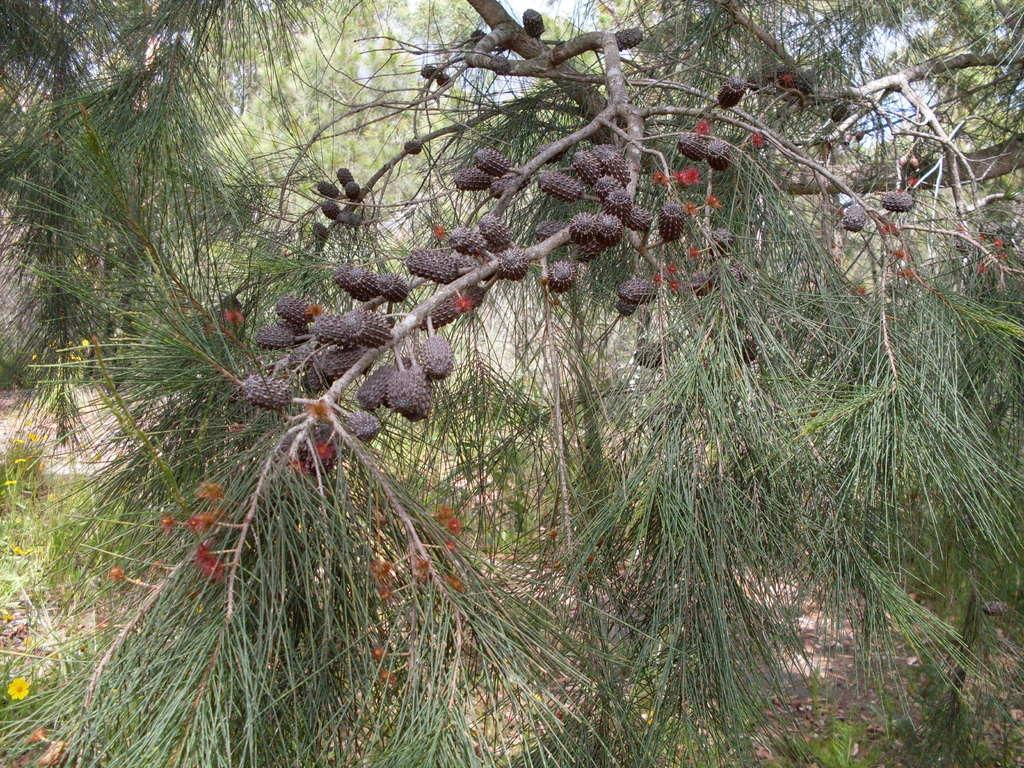What is present on the tree in the image? There are flowers and fruits on the tree in the image. What can be seen in the background of the image? There are trees visible at the back. What is visible at the top of the image? The sky is visible at the top. What is visible at the bottom of the image? The ground is visible at the bottom. Can you see any chickens pecking at the fruits in the image? There are no chickens present in the image. Is there a river flowing through the image? There is no river visible in the image. 